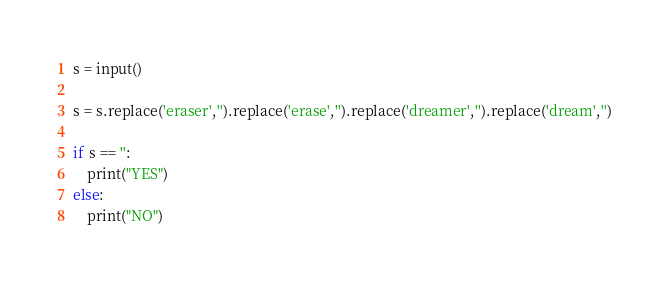Convert code to text. <code><loc_0><loc_0><loc_500><loc_500><_Python_>s = input()

s = s.replace('eraser','').replace('erase','').replace('dreamer','').replace('dream','')

if s == '':
    print("YES")
else:
    print("NO")</code> 